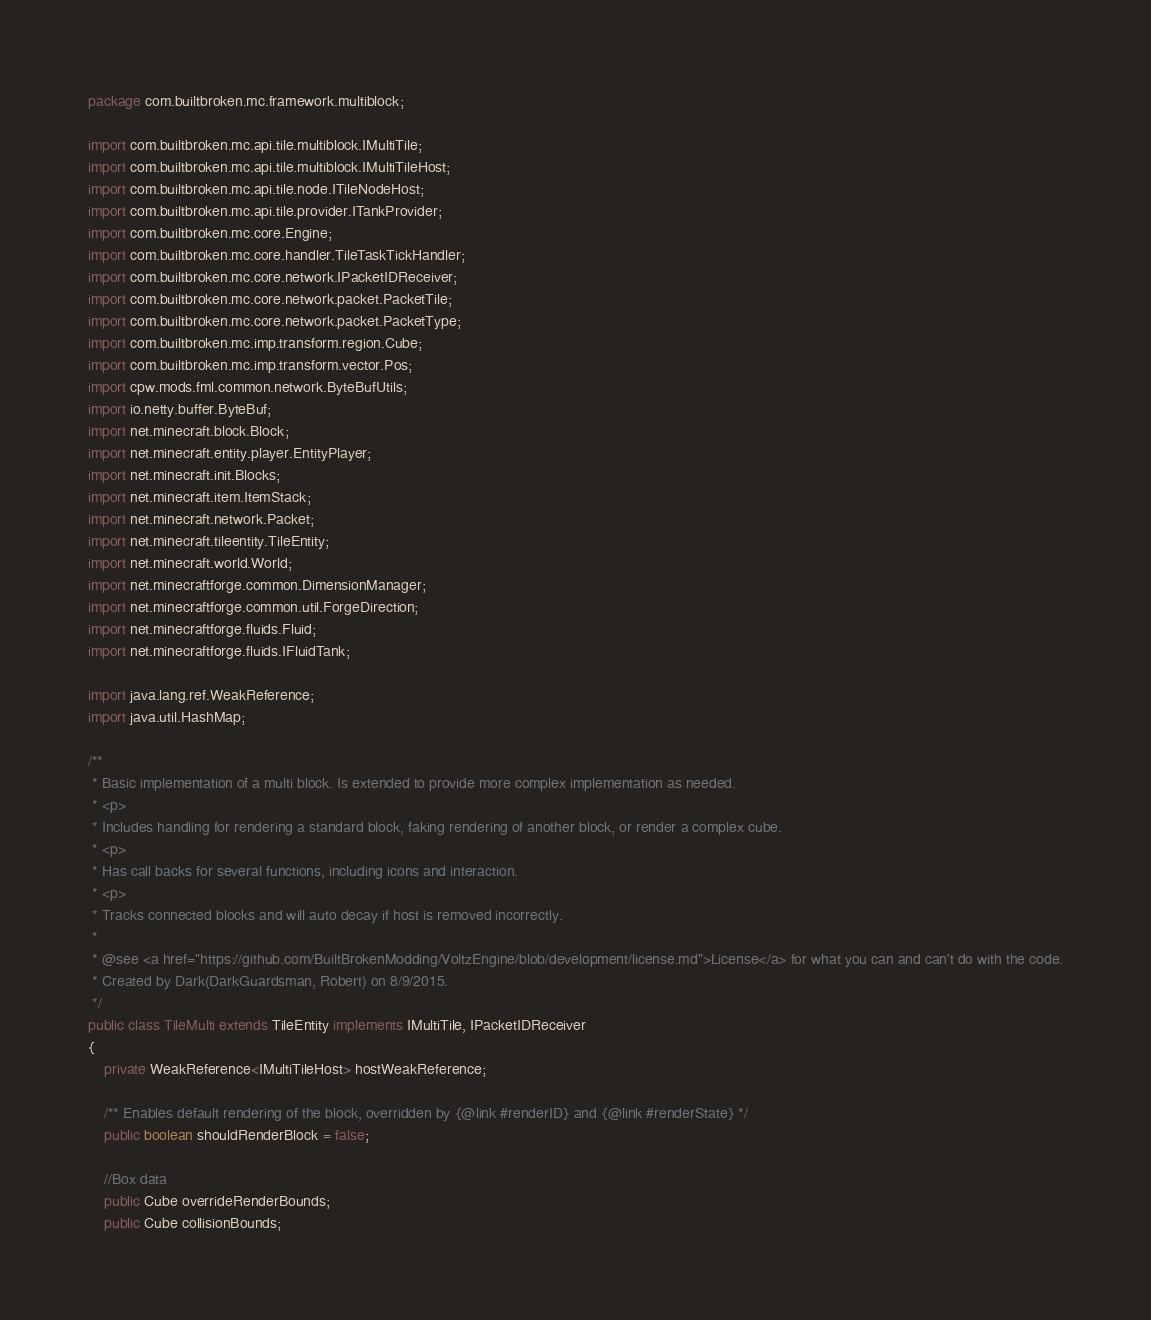Convert code to text. <code><loc_0><loc_0><loc_500><loc_500><_Java_>package com.builtbroken.mc.framework.multiblock;

import com.builtbroken.mc.api.tile.multiblock.IMultiTile;
import com.builtbroken.mc.api.tile.multiblock.IMultiTileHost;
import com.builtbroken.mc.api.tile.node.ITileNodeHost;
import com.builtbroken.mc.api.tile.provider.ITankProvider;
import com.builtbroken.mc.core.Engine;
import com.builtbroken.mc.core.handler.TileTaskTickHandler;
import com.builtbroken.mc.core.network.IPacketIDReceiver;
import com.builtbroken.mc.core.network.packet.PacketTile;
import com.builtbroken.mc.core.network.packet.PacketType;
import com.builtbroken.mc.imp.transform.region.Cube;
import com.builtbroken.mc.imp.transform.vector.Pos;
import cpw.mods.fml.common.network.ByteBufUtils;
import io.netty.buffer.ByteBuf;
import net.minecraft.block.Block;
import net.minecraft.entity.player.EntityPlayer;
import net.minecraft.init.Blocks;
import net.minecraft.item.ItemStack;
import net.minecraft.network.Packet;
import net.minecraft.tileentity.TileEntity;
import net.minecraft.world.World;
import net.minecraftforge.common.DimensionManager;
import net.minecraftforge.common.util.ForgeDirection;
import net.minecraftforge.fluids.Fluid;
import net.minecraftforge.fluids.IFluidTank;

import java.lang.ref.WeakReference;
import java.util.HashMap;

/**
 * Basic implementation of a multi block. Is extended to provide more complex implementation as needed.
 * <p>
 * Includes handling for rendering a standard block, faking rendering of another block, or render a complex cube.
 * <p>
 * Has call backs for several functions, including icons and interaction.
 * <p>
 * Tracks connected blocks and will auto decay if host is removed incorrectly.
 *
 * @see <a href="https://github.com/BuiltBrokenModding/VoltzEngine/blob/development/license.md">License</a> for what you can and can't do with the code.
 * Created by Dark(DarkGuardsman, Robert) on 8/9/2015.
 */
public class TileMulti extends TileEntity implements IMultiTile, IPacketIDReceiver
{
    private WeakReference<IMultiTileHost> hostWeakReference;

    /** Enables default rendering of the block, overridden by {@link #renderID} and {@link #renderState} */
    public boolean shouldRenderBlock = false;

    //Box data
    public Cube overrideRenderBounds;
    public Cube collisionBounds;
</code> 